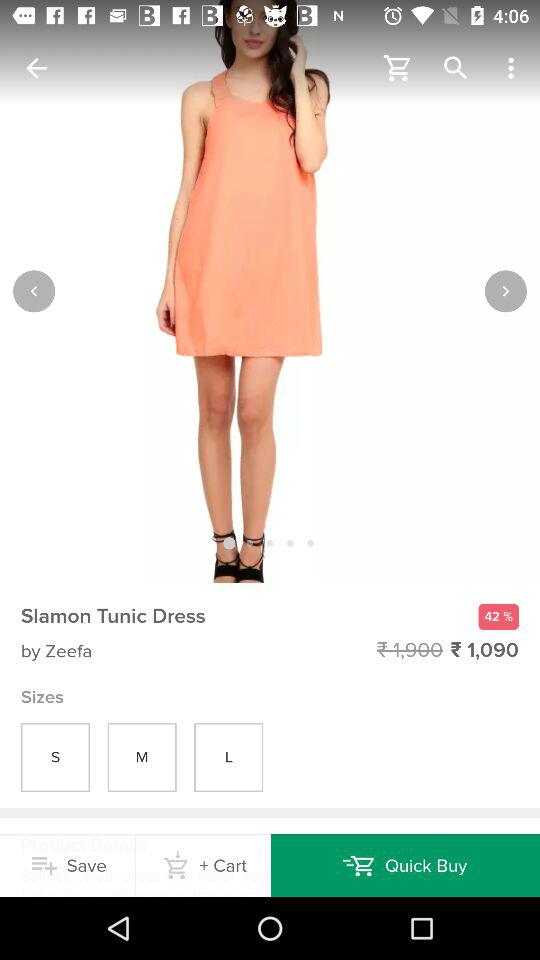What was the original price of the dress? The original price of the dress was ₹1,900. 